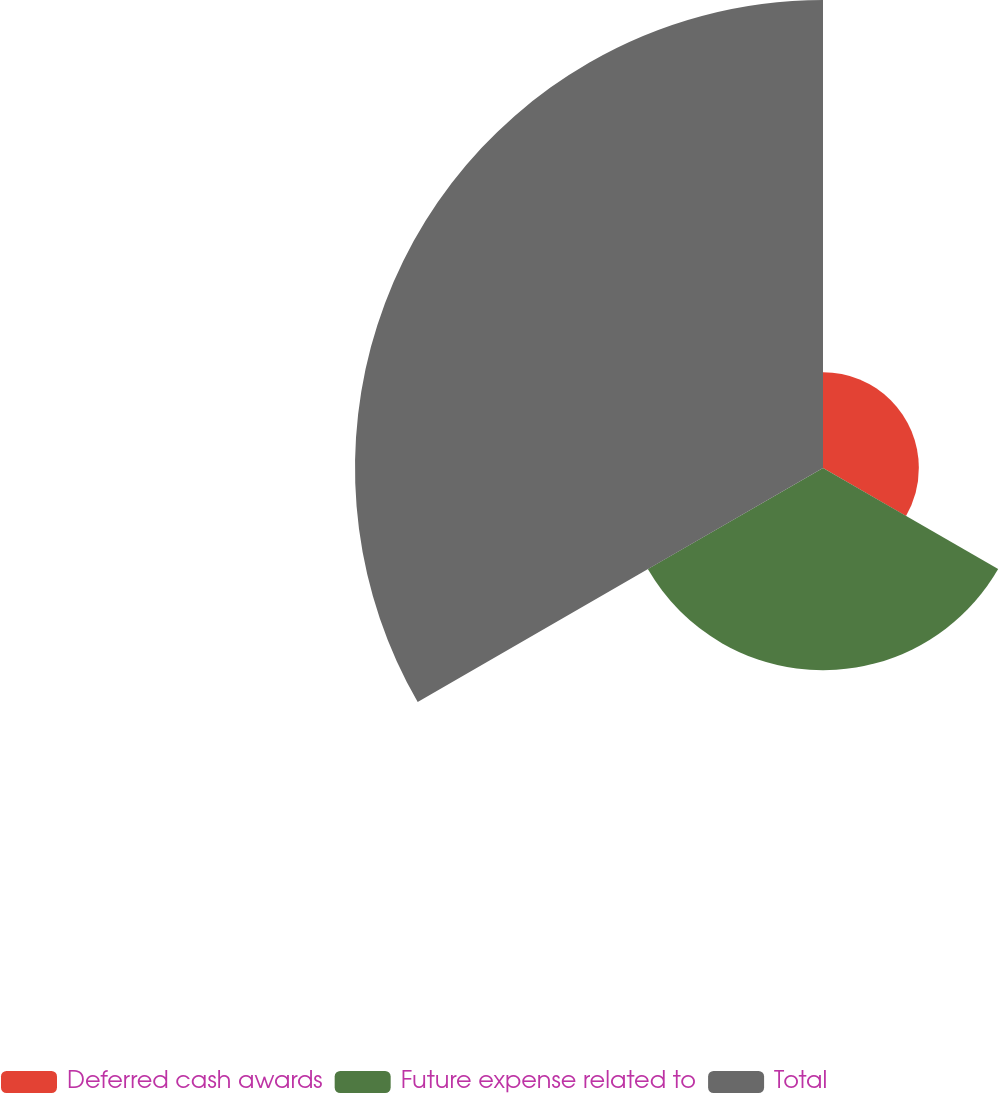<chart> <loc_0><loc_0><loc_500><loc_500><pie_chart><fcel>Deferred cash awards<fcel>Future expense related to<fcel>Total<nl><fcel>12.51%<fcel>26.4%<fcel>61.09%<nl></chart> 